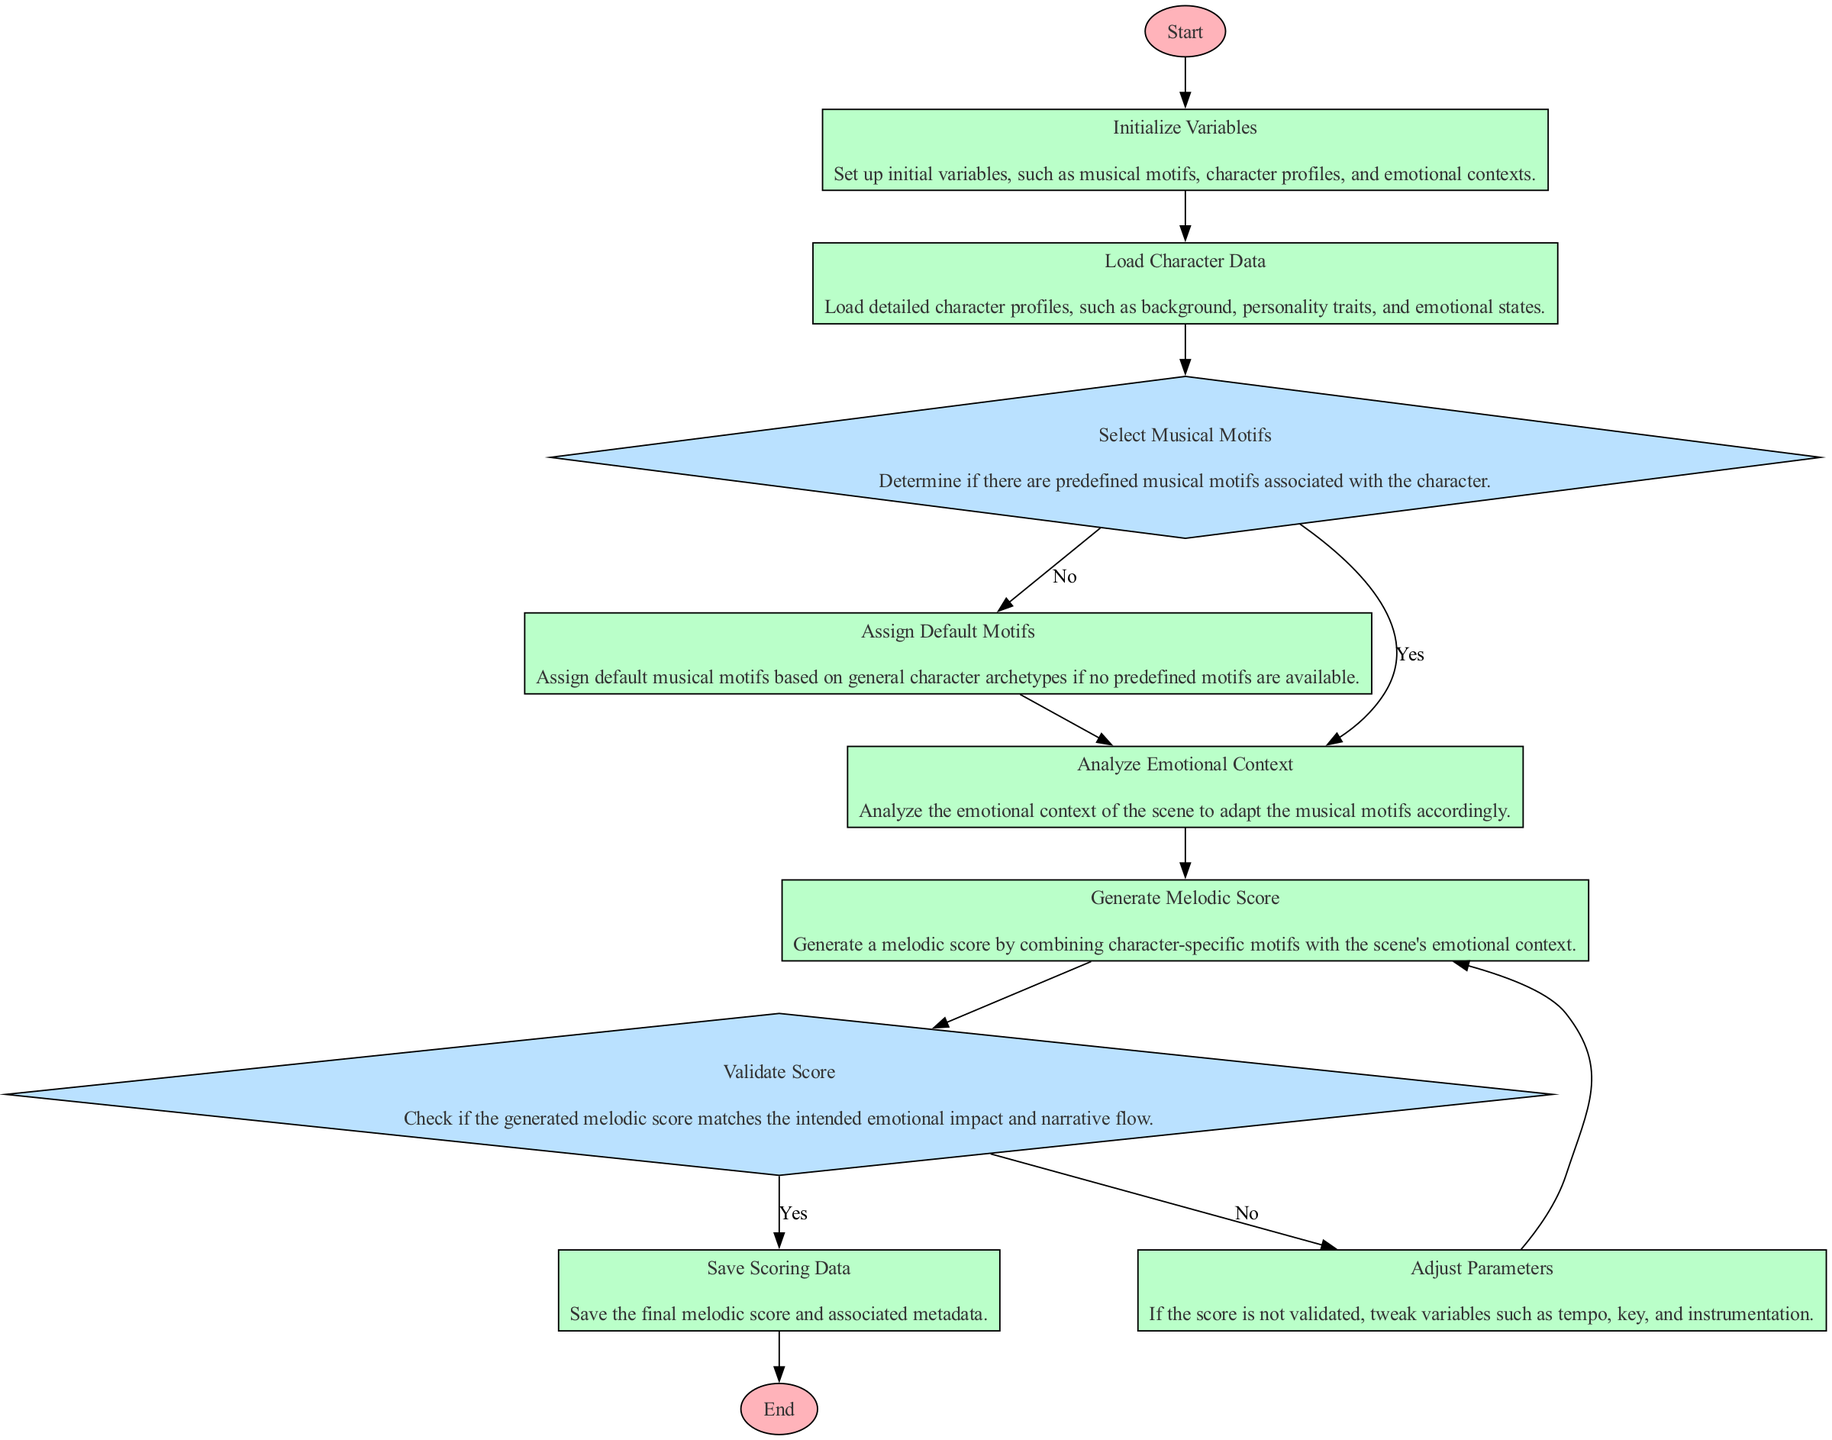What is the first step in the process? The first step is labeled "Start," indicating the initiation of the flowchart. It sets the stage for the subsequent processes and decisions.
Answer: Start What element follows "Load Character Data"? After "Load Character Data," the next element in the flowchart is "Select Musical Motifs," which transitions from loading the character profiles to determining musical motifs.
Answer: Select Musical Motifs How many decision nodes are present in the diagram? There are three decision nodes: "Select Musical Motifs," "Validate Score," and one implicit decision for skipping potential motifs. Each decision node indicates a point where a choice must be made.
Answer: Three What happens if no predefined motifs are associated with the character? If there are no predefined motifs, the flowchart indicates that the process will direct to "Assign Default Motifs," where general motifs based on archetypes are assigned.
Answer: Assign Default Motifs What should be done if the score is not validated? If the generated melodic score is not validated, the flowchart directs to "Adjust Parameters," where tweaks to variables like tempo, key, and instrumentation are made to improve the score.
Answer: Adjust Parameters What is the final action taken in the process? The final action taken in the process is "Save Scoring Data," which indicates the completion of the melodic scoring system by saving the final information.
Answer: Save Scoring Data Which process comes after "Analyze Emotional Context"? The process that follows "Analyze Emotional Context" is "Generate Melodic Score," indicating that after analyzing the emotional context, the score is created.
Answer: Generate Melodic Score What leads to the end of the flowchart? The end of the flowchart is reached after "Save Scoring Data," indicating that all processes have been completed before concluding the scoring system.
Answer: End 